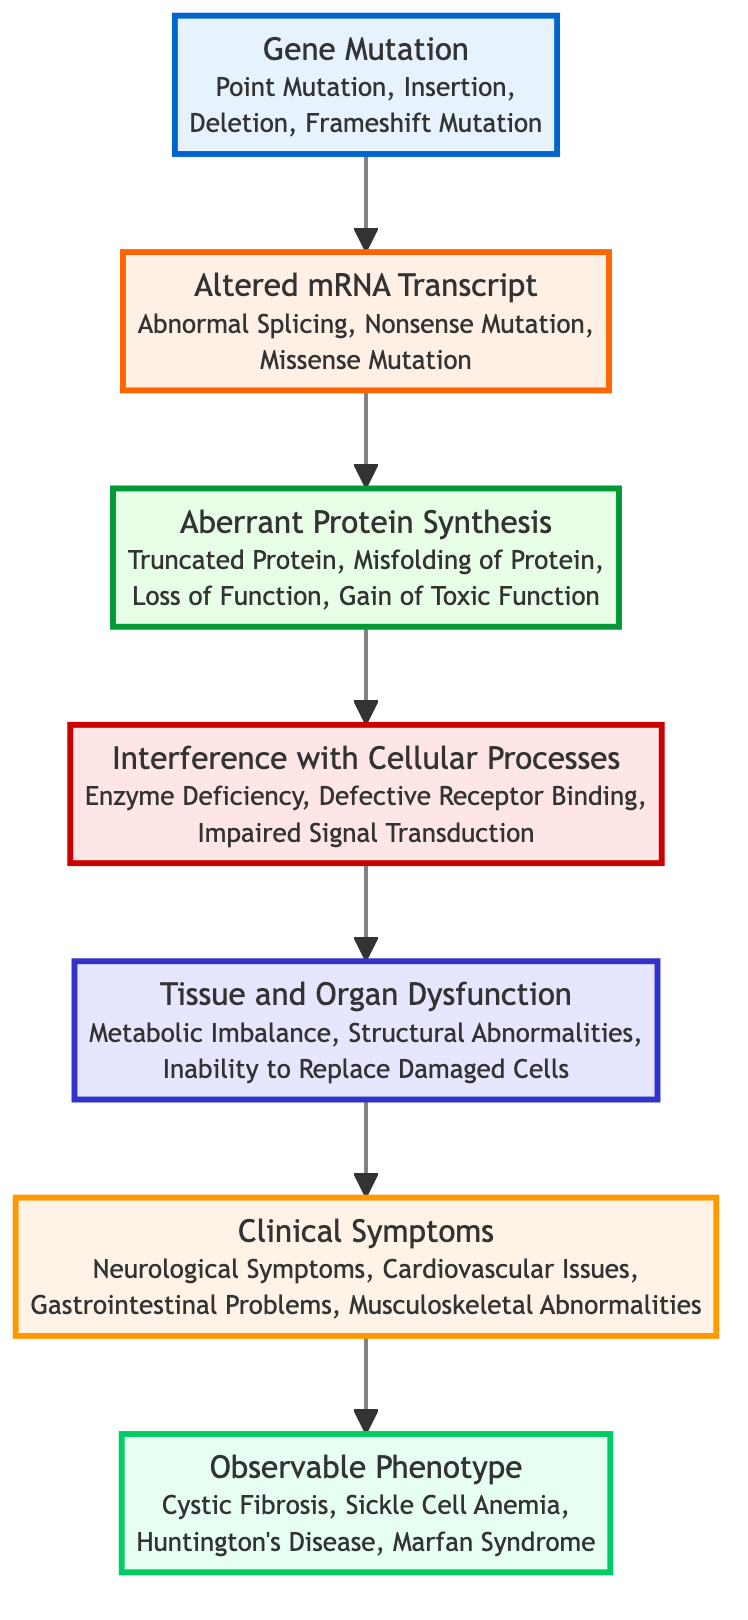What is the first node in the diagram? The first node at the bottom of the diagram is "Gene Mutation." It is the starting point of the flow chart indicating the foundation of the genetic disorder pathway.
Answer: Gene Mutation How many levels are depicted in the diagram? The diagram contains seven distinct levels, starting from "Gene Mutation" at the bottom to "Observable Phenotype" at the top. Each level represents a step in the pathway of genetic disorders.
Answer: 7 What type of mutation is included in the first node? The first node, "Gene Mutation," specifies several types of genetic mutations, including "Point Mutation," which is one of the categories listed under this node.
Answer: Point Mutation Which level directly follows "Aberrant Protein Synthesis"? The level that directly follows "Aberrant Protein Synthesis" is "Interference with Cellular Processes." This indicates that the next step after aberrant protein synthesis is the interference with normal cellular processes.
Answer: Interference with Cellular Processes What is the final node representing the observable outcome in this pathway? The final node at the top of the diagram is "Observable Phenotype," which represents the observable characteristics resulting from prior steps in the flow.
Answer: Observable Phenotype What are the clinical symptoms associated with the last stage before the observable phenotype? The clinical symptoms listed just before reaching the "Observable Phenotype" node include "Neurological Symptoms." These represent the health issues that arise from the preceding processes in the chart.
Answer: Neurological Symptoms How many types of gene mutations are mentioned in the diagram? The diagram lists four types of gene mutations: "Point Mutation," "Insertion," "Deletion," and "Frameshift Mutation." This indicates a diverse range of ways genetic information can be altered.
Answer: 4 What changes occur after the "Altered mRNA Transcript"? After the "Altered mRNA Transcript," the next stage is "Aberrant Protein Synthesis," illustrating that alterations in mRNA result in irregular protein synthesis.
Answer: Aberrant Protein Synthesis Which condition is an example of an observable phenotype? The observable phenotype depicted in the top node includes "Cystic Fibrosis," which is a specific example of a genetic disorder resulting from the mutations and processes described below it.
Answer: Cystic Fibrosis 